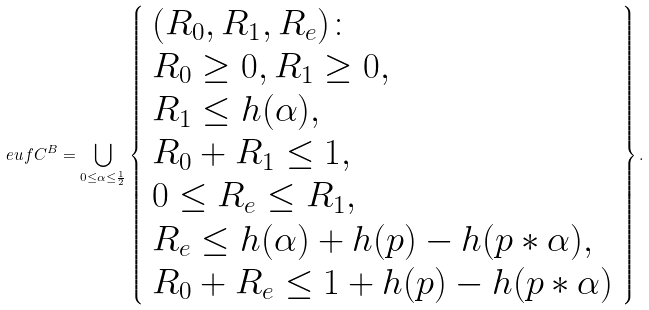Convert formula to latex. <formula><loc_0><loc_0><loc_500><loc_500>\ e u f C ^ { B } = \bigcup _ { 0 \leq \alpha \leq \frac { 1 } { 2 } } \left \{ \begin{array} { l } ( R _ { 0 } , R _ { 1 } , R _ { e } ) \colon \\ R _ { 0 } \geq 0 , R _ { 1 } \geq 0 , \\ R _ { 1 } \leq h ( \alpha ) , \\ R _ { 0 } + R _ { 1 } \leq 1 , \\ 0 \leq R _ { e } \leq R _ { 1 } , \\ R _ { e } \leq h ( \alpha ) + h ( p ) - h ( p * \alpha ) , \\ R _ { 0 } + R _ { e } \leq 1 + h ( p ) - h ( p * \alpha ) \end{array} \right \} .</formula> 